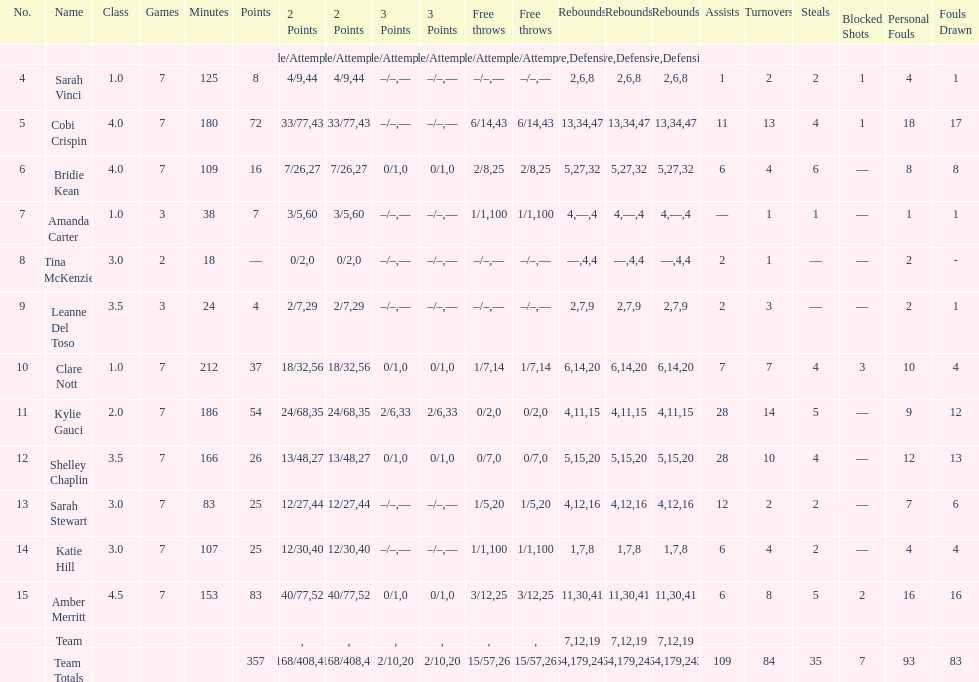Total number of assists and turnovers combined 193. Help me parse the entirety of this table. {'header': ['No.', 'Name', 'Class', 'Games', 'Minutes', 'Points', '2 Points', '2 Points', '3 Points', '3 Points', 'Free throws', 'Free throws', 'Rebounds', 'Rebounds', 'Rebounds', 'Assists', 'Turnovers', 'Steals', 'Blocked Shots', 'Personal Fouls', 'Fouls Drawn'], 'rows': [['', '', '', '', '', '', 'Made/Attempts', '%', 'Made/Attempts', '%', 'Made/Attempts', '%', 'Offensive', 'Defensive', 'Total', '', '', '', '', '', ''], ['4', 'Sarah Vinci', '1.0', '7', '125', '8', '4/9', '44', '–/–', '—', '–/–', '—', '2', '6', '8', '1', '2', '2', '1', '4', '1'], ['5', 'Cobi Crispin', '4.0', '7', '180', '72', '33/77', '43', '–/–', '—', '6/14', '43', '13', '34', '47', '11', '13', '4', '1', '18', '17'], ['6', 'Bridie Kean', '4.0', '7', '109', '16', '7/26', '27', '0/1', '0', '2/8', '25', '5', '27', '32', '6', '4', '6', '—', '8', '8'], ['7', 'Amanda Carter', '1.0', '3', '38', '7', '3/5', '60', '–/–', '—', '1/1', '100', '4', '—', '4', '—', '1', '1', '—', '1', '1'], ['8', 'Tina McKenzie', '3.0', '2', '18', '—', '0/2', '0', '–/–', '—', '–/–', '—', '—', '4', '4', '2', '1', '—', '—', '2', '-'], ['9', 'Leanne Del Toso', '3.5', '3', '24', '4', '2/7', '29', '–/–', '—', '–/–', '—', '2', '7', '9', '2', '3', '—', '—', '2', '1'], ['10', 'Clare Nott', '1.0', '7', '212', '37', '18/32', '56', '0/1', '0', '1/7', '14', '6', '14', '20', '7', '7', '4', '3', '10', '4'], ['11', 'Kylie Gauci', '2.0', '7', '186', '54', '24/68', '35', '2/6', '33', '0/2', '0', '4', '11', '15', '28', '14', '5', '—', '9', '12'], ['12', 'Shelley Chaplin', '3.5', '7', '166', '26', '13/48', '27', '0/1', '0', '0/7', '0', '5', '15', '20', '28', '10', '4', '—', '12', '13'], ['13', 'Sarah Stewart', '3.0', '7', '83', '25', '12/27', '44', '–/–', '—', '1/5', '20', '4', '12', '16', '12', '2', '2', '—', '7', '6'], ['14', 'Katie Hill', '3.0', '7', '107', '25', '12/30', '40', '–/–', '—', '1/1', '100', '1', '7', '8', '6', '4', '2', '—', '4', '4'], ['15', 'Amber Merritt', '4.5', '7', '153', '83', '40/77', '52', '0/1', '0', '3/12', '25', '11', '30', '41', '6', '8', '5', '2', '16', '16'], ['', 'Team', '', '', '', '', '', '', '', '', '', '', '7', '12', '19', '', '', '', '', '', ''], ['', 'Team Totals', '', '', '', '357', '168/408', '41', '2/10', '20', '15/57', '26', '64', '179', '243', '109', '84', '35', '7', '93', '83']]} 